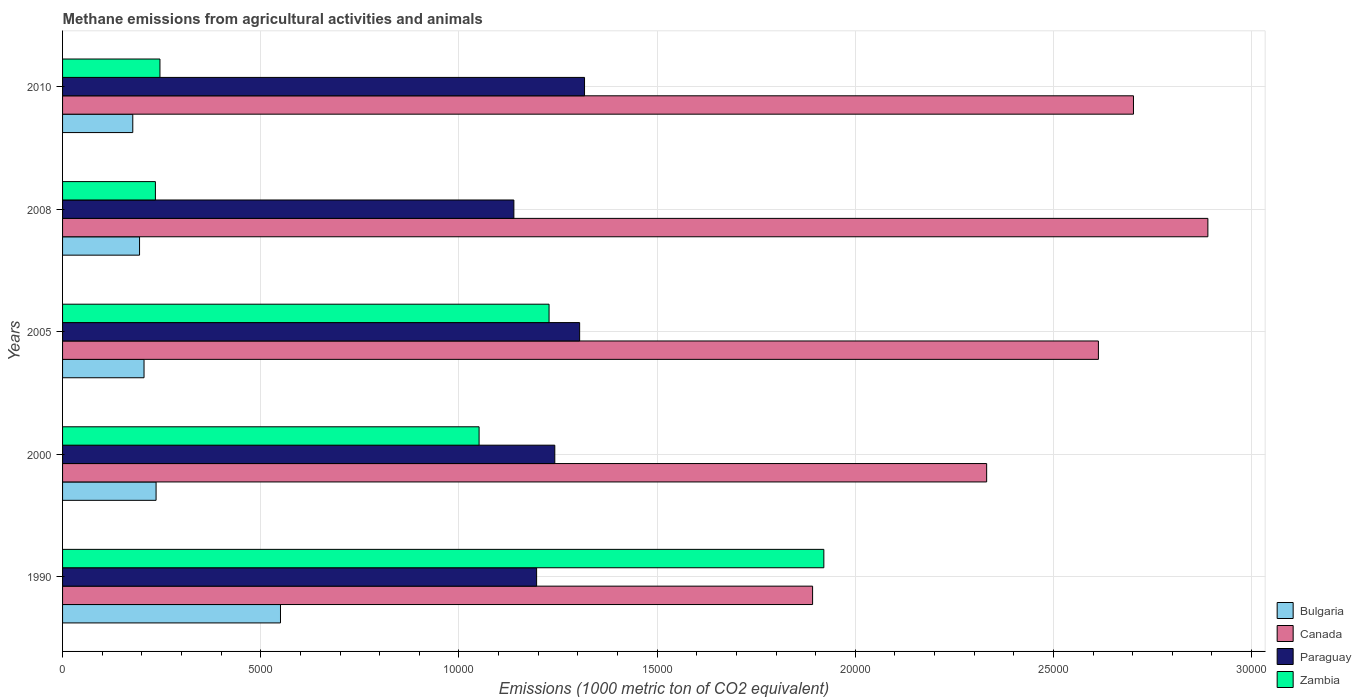How many different coloured bars are there?
Offer a very short reply. 4. Are the number of bars per tick equal to the number of legend labels?
Ensure brevity in your answer.  Yes. Are the number of bars on each tick of the Y-axis equal?
Offer a terse response. Yes. How many bars are there on the 3rd tick from the bottom?
Keep it short and to the point. 4. What is the label of the 5th group of bars from the top?
Offer a terse response. 1990. What is the amount of methane emitted in Zambia in 2010?
Keep it short and to the point. 2457.2. Across all years, what is the maximum amount of methane emitted in Bulgaria?
Your response must be concise. 5498.3. Across all years, what is the minimum amount of methane emitted in Zambia?
Offer a very short reply. 2342.5. What is the total amount of methane emitted in Canada in the graph?
Your answer should be compact. 1.24e+05. What is the difference between the amount of methane emitted in Zambia in 1990 and that in 2008?
Give a very brief answer. 1.69e+04. What is the difference between the amount of methane emitted in Paraguay in 2000 and the amount of methane emitted in Bulgaria in 2008?
Provide a succinct answer. 1.05e+04. What is the average amount of methane emitted in Canada per year?
Provide a short and direct response. 2.49e+04. In the year 1990, what is the difference between the amount of methane emitted in Paraguay and amount of methane emitted in Canada?
Offer a terse response. -6963.1. In how many years, is the amount of methane emitted in Zambia greater than 13000 1000 metric ton?
Offer a very short reply. 1. What is the ratio of the amount of methane emitted in Canada in 2000 to that in 2010?
Your answer should be compact. 0.86. Is the amount of methane emitted in Canada in 2000 less than that in 2005?
Make the answer very short. Yes. Is the difference between the amount of methane emitted in Paraguay in 2008 and 2010 greater than the difference between the amount of methane emitted in Canada in 2008 and 2010?
Make the answer very short. No. What is the difference between the highest and the second highest amount of methane emitted in Paraguay?
Your answer should be very brief. 123.2. What is the difference between the highest and the lowest amount of methane emitted in Canada?
Your answer should be very brief. 9973.1. In how many years, is the amount of methane emitted in Canada greater than the average amount of methane emitted in Canada taken over all years?
Keep it short and to the point. 3. Is the sum of the amount of methane emitted in Bulgaria in 2000 and 2005 greater than the maximum amount of methane emitted in Zambia across all years?
Make the answer very short. No. Is it the case that in every year, the sum of the amount of methane emitted in Paraguay and amount of methane emitted in Zambia is greater than the sum of amount of methane emitted in Canada and amount of methane emitted in Bulgaria?
Offer a terse response. No. What does the 2nd bar from the bottom in 2005 represents?
Make the answer very short. Canada. How many bars are there?
Ensure brevity in your answer.  20. How many years are there in the graph?
Your answer should be very brief. 5. Are the values on the major ticks of X-axis written in scientific E-notation?
Ensure brevity in your answer.  No. Where does the legend appear in the graph?
Provide a succinct answer. Bottom right. How many legend labels are there?
Your response must be concise. 4. How are the legend labels stacked?
Provide a succinct answer. Vertical. What is the title of the graph?
Your response must be concise. Methane emissions from agricultural activities and animals. What is the label or title of the X-axis?
Your response must be concise. Emissions (1000 metric ton of CO2 equivalent). What is the Emissions (1000 metric ton of CO2 equivalent) in Bulgaria in 1990?
Your answer should be compact. 5498.3. What is the Emissions (1000 metric ton of CO2 equivalent) of Canada in 1990?
Provide a short and direct response. 1.89e+04. What is the Emissions (1000 metric ton of CO2 equivalent) in Paraguay in 1990?
Your answer should be very brief. 1.20e+04. What is the Emissions (1000 metric ton of CO2 equivalent) of Zambia in 1990?
Make the answer very short. 1.92e+04. What is the Emissions (1000 metric ton of CO2 equivalent) in Bulgaria in 2000?
Keep it short and to the point. 2359.5. What is the Emissions (1000 metric ton of CO2 equivalent) in Canada in 2000?
Ensure brevity in your answer.  2.33e+04. What is the Emissions (1000 metric ton of CO2 equivalent) in Paraguay in 2000?
Make the answer very short. 1.24e+04. What is the Emissions (1000 metric ton of CO2 equivalent) in Zambia in 2000?
Give a very brief answer. 1.05e+04. What is the Emissions (1000 metric ton of CO2 equivalent) in Bulgaria in 2005?
Offer a very short reply. 2055.2. What is the Emissions (1000 metric ton of CO2 equivalent) of Canada in 2005?
Make the answer very short. 2.61e+04. What is the Emissions (1000 metric ton of CO2 equivalent) in Paraguay in 2005?
Your response must be concise. 1.30e+04. What is the Emissions (1000 metric ton of CO2 equivalent) of Zambia in 2005?
Give a very brief answer. 1.23e+04. What is the Emissions (1000 metric ton of CO2 equivalent) of Bulgaria in 2008?
Make the answer very short. 1942.2. What is the Emissions (1000 metric ton of CO2 equivalent) of Canada in 2008?
Offer a very short reply. 2.89e+04. What is the Emissions (1000 metric ton of CO2 equivalent) of Paraguay in 2008?
Your answer should be very brief. 1.14e+04. What is the Emissions (1000 metric ton of CO2 equivalent) in Zambia in 2008?
Offer a very short reply. 2342.5. What is the Emissions (1000 metric ton of CO2 equivalent) of Bulgaria in 2010?
Provide a short and direct response. 1771.6. What is the Emissions (1000 metric ton of CO2 equivalent) of Canada in 2010?
Make the answer very short. 2.70e+04. What is the Emissions (1000 metric ton of CO2 equivalent) in Paraguay in 2010?
Keep it short and to the point. 1.32e+04. What is the Emissions (1000 metric ton of CO2 equivalent) of Zambia in 2010?
Provide a short and direct response. 2457.2. Across all years, what is the maximum Emissions (1000 metric ton of CO2 equivalent) in Bulgaria?
Provide a short and direct response. 5498.3. Across all years, what is the maximum Emissions (1000 metric ton of CO2 equivalent) of Canada?
Offer a very short reply. 2.89e+04. Across all years, what is the maximum Emissions (1000 metric ton of CO2 equivalent) of Paraguay?
Give a very brief answer. 1.32e+04. Across all years, what is the maximum Emissions (1000 metric ton of CO2 equivalent) of Zambia?
Keep it short and to the point. 1.92e+04. Across all years, what is the minimum Emissions (1000 metric ton of CO2 equivalent) of Bulgaria?
Offer a terse response. 1771.6. Across all years, what is the minimum Emissions (1000 metric ton of CO2 equivalent) of Canada?
Your answer should be very brief. 1.89e+04. Across all years, what is the minimum Emissions (1000 metric ton of CO2 equivalent) in Paraguay?
Your response must be concise. 1.14e+04. Across all years, what is the minimum Emissions (1000 metric ton of CO2 equivalent) in Zambia?
Ensure brevity in your answer.  2342.5. What is the total Emissions (1000 metric ton of CO2 equivalent) of Bulgaria in the graph?
Your response must be concise. 1.36e+04. What is the total Emissions (1000 metric ton of CO2 equivalent) of Canada in the graph?
Provide a short and direct response. 1.24e+05. What is the total Emissions (1000 metric ton of CO2 equivalent) in Paraguay in the graph?
Your response must be concise. 6.20e+04. What is the total Emissions (1000 metric ton of CO2 equivalent) of Zambia in the graph?
Give a very brief answer. 4.68e+04. What is the difference between the Emissions (1000 metric ton of CO2 equivalent) in Bulgaria in 1990 and that in 2000?
Give a very brief answer. 3138.8. What is the difference between the Emissions (1000 metric ton of CO2 equivalent) of Canada in 1990 and that in 2000?
Provide a succinct answer. -4391.7. What is the difference between the Emissions (1000 metric ton of CO2 equivalent) of Paraguay in 1990 and that in 2000?
Give a very brief answer. -458.8. What is the difference between the Emissions (1000 metric ton of CO2 equivalent) of Zambia in 1990 and that in 2000?
Provide a short and direct response. 8698.2. What is the difference between the Emissions (1000 metric ton of CO2 equivalent) of Bulgaria in 1990 and that in 2005?
Offer a very short reply. 3443.1. What is the difference between the Emissions (1000 metric ton of CO2 equivalent) in Canada in 1990 and that in 2005?
Offer a very short reply. -7210.8. What is the difference between the Emissions (1000 metric ton of CO2 equivalent) of Paraguay in 1990 and that in 2005?
Keep it short and to the point. -1085.6. What is the difference between the Emissions (1000 metric ton of CO2 equivalent) of Zambia in 1990 and that in 2005?
Your response must be concise. 6932.6. What is the difference between the Emissions (1000 metric ton of CO2 equivalent) of Bulgaria in 1990 and that in 2008?
Give a very brief answer. 3556.1. What is the difference between the Emissions (1000 metric ton of CO2 equivalent) of Canada in 1990 and that in 2008?
Your answer should be compact. -9973.1. What is the difference between the Emissions (1000 metric ton of CO2 equivalent) in Paraguay in 1990 and that in 2008?
Offer a terse response. 573.8. What is the difference between the Emissions (1000 metric ton of CO2 equivalent) in Zambia in 1990 and that in 2008?
Give a very brief answer. 1.69e+04. What is the difference between the Emissions (1000 metric ton of CO2 equivalent) in Bulgaria in 1990 and that in 2010?
Keep it short and to the point. 3726.7. What is the difference between the Emissions (1000 metric ton of CO2 equivalent) of Canada in 1990 and that in 2010?
Your response must be concise. -8095.8. What is the difference between the Emissions (1000 metric ton of CO2 equivalent) in Paraguay in 1990 and that in 2010?
Your answer should be very brief. -1208.8. What is the difference between the Emissions (1000 metric ton of CO2 equivalent) of Zambia in 1990 and that in 2010?
Provide a short and direct response. 1.67e+04. What is the difference between the Emissions (1000 metric ton of CO2 equivalent) in Bulgaria in 2000 and that in 2005?
Offer a terse response. 304.3. What is the difference between the Emissions (1000 metric ton of CO2 equivalent) in Canada in 2000 and that in 2005?
Your answer should be very brief. -2819.1. What is the difference between the Emissions (1000 metric ton of CO2 equivalent) in Paraguay in 2000 and that in 2005?
Give a very brief answer. -626.8. What is the difference between the Emissions (1000 metric ton of CO2 equivalent) of Zambia in 2000 and that in 2005?
Provide a short and direct response. -1765.6. What is the difference between the Emissions (1000 metric ton of CO2 equivalent) of Bulgaria in 2000 and that in 2008?
Your answer should be very brief. 417.3. What is the difference between the Emissions (1000 metric ton of CO2 equivalent) of Canada in 2000 and that in 2008?
Make the answer very short. -5581.4. What is the difference between the Emissions (1000 metric ton of CO2 equivalent) of Paraguay in 2000 and that in 2008?
Provide a succinct answer. 1032.6. What is the difference between the Emissions (1000 metric ton of CO2 equivalent) in Zambia in 2000 and that in 2008?
Offer a very short reply. 8166.4. What is the difference between the Emissions (1000 metric ton of CO2 equivalent) of Bulgaria in 2000 and that in 2010?
Give a very brief answer. 587.9. What is the difference between the Emissions (1000 metric ton of CO2 equivalent) of Canada in 2000 and that in 2010?
Your answer should be very brief. -3704.1. What is the difference between the Emissions (1000 metric ton of CO2 equivalent) of Paraguay in 2000 and that in 2010?
Give a very brief answer. -750. What is the difference between the Emissions (1000 metric ton of CO2 equivalent) in Zambia in 2000 and that in 2010?
Your response must be concise. 8051.7. What is the difference between the Emissions (1000 metric ton of CO2 equivalent) in Bulgaria in 2005 and that in 2008?
Keep it short and to the point. 113. What is the difference between the Emissions (1000 metric ton of CO2 equivalent) in Canada in 2005 and that in 2008?
Offer a terse response. -2762.3. What is the difference between the Emissions (1000 metric ton of CO2 equivalent) in Paraguay in 2005 and that in 2008?
Ensure brevity in your answer.  1659.4. What is the difference between the Emissions (1000 metric ton of CO2 equivalent) in Zambia in 2005 and that in 2008?
Offer a terse response. 9932. What is the difference between the Emissions (1000 metric ton of CO2 equivalent) of Bulgaria in 2005 and that in 2010?
Your answer should be very brief. 283.6. What is the difference between the Emissions (1000 metric ton of CO2 equivalent) of Canada in 2005 and that in 2010?
Your answer should be compact. -885. What is the difference between the Emissions (1000 metric ton of CO2 equivalent) in Paraguay in 2005 and that in 2010?
Your answer should be compact. -123.2. What is the difference between the Emissions (1000 metric ton of CO2 equivalent) of Zambia in 2005 and that in 2010?
Your answer should be compact. 9817.3. What is the difference between the Emissions (1000 metric ton of CO2 equivalent) in Bulgaria in 2008 and that in 2010?
Make the answer very short. 170.6. What is the difference between the Emissions (1000 metric ton of CO2 equivalent) in Canada in 2008 and that in 2010?
Offer a terse response. 1877.3. What is the difference between the Emissions (1000 metric ton of CO2 equivalent) of Paraguay in 2008 and that in 2010?
Your answer should be very brief. -1782.6. What is the difference between the Emissions (1000 metric ton of CO2 equivalent) of Zambia in 2008 and that in 2010?
Provide a short and direct response. -114.7. What is the difference between the Emissions (1000 metric ton of CO2 equivalent) of Bulgaria in 1990 and the Emissions (1000 metric ton of CO2 equivalent) of Canada in 2000?
Your answer should be very brief. -1.78e+04. What is the difference between the Emissions (1000 metric ton of CO2 equivalent) in Bulgaria in 1990 and the Emissions (1000 metric ton of CO2 equivalent) in Paraguay in 2000?
Your response must be concise. -6920.9. What is the difference between the Emissions (1000 metric ton of CO2 equivalent) in Bulgaria in 1990 and the Emissions (1000 metric ton of CO2 equivalent) in Zambia in 2000?
Offer a very short reply. -5010.6. What is the difference between the Emissions (1000 metric ton of CO2 equivalent) of Canada in 1990 and the Emissions (1000 metric ton of CO2 equivalent) of Paraguay in 2000?
Give a very brief answer. 6504.3. What is the difference between the Emissions (1000 metric ton of CO2 equivalent) of Canada in 1990 and the Emissions (1000 metric ton of CO2 equivalent) of Zambia in 2000?
Provide a succinct answer. 8414.6. What is the difference between the Emissions (1000 metric ton of CO2 equivalent) in Paraguay in 1990 and the Emissions (1000 metric ton of CO2 equivalent) in Zambia in 2000?
Your response must be concise. 1451.5. What is the difference between the Emissions (1000 metric ton of CO2 equivalent) of Bulgaria in 1990 and the Emissions (1000 metric ton of CO2 equivalent) of Canada in 2005?
Your answer should be very brief. -2.06e+04. What is the difference between the Emissions (1000 metric ton of CO2 equivalent) of Bulgaria in 1990 and the Emissions (1000 metric ton of CO2 equivalent) of Paraguay in 2005?
Offer a terse response. -7547.7. What is the difference between the Emissions (1000 metric ton of CO2 equivalent) in Bulgaria in 1990 and the Emissions (1000 metric ton of CO2 equivalent) in Zambia in 2005?
Your answer should be very brief. -6776.2. What is the difference between the Emissions (1000 metric ton of CO2 equivalent) in Canada in 1990 and the Emissions (1000 metric ton of CO2 equivalent) in Paraguay in 2005?
Provide a short and direct response. 5877.5. What is the difference between the Emissions (1000 metric ton of CO2 equivalent) in Canada in 1990 and the Emissions (1000 metric ton of CO2 equivalent) in Zambia in 2005?
Ensure brevity in your answer.  6649. What is the difference between the Emissions (1000 metric ton of CO2 equivalent) in Paraguay in 1990 and the Emissions (1000 metric ton of CO2 equivalent) in Zambia in 2005?
Keep it short and to the point. -314.1. What is the difference between the Emissions (1000 metric ton of CO2 equivalent) in Bulgaria in 1990 and the Emissions (1000 metric ton of CO2 equivalent) in Canada in 2008?
Provide a short and direct response. -2.34e+04. What is the difference between the Emissions (1000 metric ton of CO2 equivalent) in Bulgaria in 1990 and the Emissions (1000 metric ton of CO2 equivalent) in Paraguay in 2008?
Provide a short and direct response. -5888.3. What is the difference between the Emissions (1000 metric ton of CO2 equivalent) of Bulgaria in 1990 and the Emissions (1000 metric ton of CO2 equivalent) of Zambia in 2008?
Your answer should be compact. 3155.8. What is the difference between the Emissions (1000 metric ton of CO2 equivalent) of Canada in 1990 and the Emissions (1000 metric ton of CO2 equivalent) of Paraguay in 2008?
Ensure brevity in your answer.  7536.9. What is the difference between the Emissions (1000 metric ton of CO2 equivalent) of Canada in 1990 and the Emissions (1000 metric ton of CO2 equivalent) of Zambia in 2008?
Offer a terse response. 1.66e+04. What is the difference between the Emissions (1000 metric ton of CO2 equivalent) of Paraguay in 1990 and the Emissions (1000 metric ton of CO2 equivalent) of Zambia in 2008?
Your answer should be very brief. 9617.9. What is the difference between the Emissions (1000 metric ton of CO2 equivalent) in Bulgaria in 1990 and the Emissions (1000 metric ton of CO2 equivalent) in Canada in 2010?
Offer a very short reply. -2.15e+04. What is the difference between the Emissions (1000 metric ton of CO2 equivalent) of Bulgaria in 1990 and the Emissions (1000 metric ton of CO2 equivalent) of Paraguay in 2010?
Your answer should be very brief. -7670.9. What is the difference between the Emissions (1000 metric ton of CO2 equivalent) of Bulgaria in 1990 and the Emissions (1000 metric ton of CO2 equivalent) of Zambia in 2010?
Offer a very short reply. 3041.1. What is the difference between the Emissions (1000 metric ton of CO2 equivalent) of Canada in 1990 and the Emissions (1000 metric ton of CO2 equivalent) of Paraguay in 2010?
Keep it short and to the point. 5754.3. What is the difference between the Emissions (1000 metric ton of CO2 equivalent) of Canada in 1990 and the Emissions (1000 metric ton of CO2 equivalent) of Zambia in 2010?
Make the answer very short. 1.65e+04. What is the difference between the Emissions (1000 metric ton of CO2 equivalent) in Paraguay in 1990 and the Emissions (1000 metric ton of CO2 equivalent) in Zambia in 2010?
Keep it short and to the point. 9503.2. What is the difference between the Emissions (1000 metric ton of CO2 equivalent) of Bulgaria in 2000 and the Emissions (1000 metric ton of CO2 equivalent) of Canada in 2005?
Offer a very short reply. -2.38e+04. What is the difference between the Emissions (1000 metric ton of CO2 equivalent) in Bulgaria in 2000 and the Emissions (1000 metric ton of CO2 equivalent) in Paraguay in 2005?
Provide a short and direct response. -1.07e+04. What is the difference between the Emissions (1000 metric ton of CO2 equivalent) of Bulgaria in 2000 and the Emissions (1000 metric ton of CO2 equivalent) of Zambia in 2005?
Offer a very short reply. -9915. What is the difference between the Emissions (1000 metric ton of CO2 equivalent) in Canada in 2000 and the Emissions (1000 metric ton of CO2 equivalent) in Paraguay in 2005?
Make the answer very short. 1.03e+04. What is the difference between the Emissions (1000 metric ton of CO2 equivalent) of Canada in 2000 and the Emissions (1000 metric ton of CO2 equivalent) of Zambia in 2005?
Offer a very short reply. 1.10e+04. What is the difference between the Emissions (1000 metric ton of CO2 equivalent) of Paraguay in 2000 and the Emissions (1000 metric ton of CO2 equivalent) of Zambia in 2005?
Offer a very short reply. 144.7. What is the difference between the Emissions (1000 metric ton of CO2 equivalent) of Bulgaria in 2000 and the Emissions (1000 metric ton of CO2 equivalent) of Canada in 2008?
Keep it short and to the point. -2.65e+04. What is the difference between the Emissions (1000 metric ton of CO2 equivalent) of Bulgaria in 2000 and the Emissions (1000 metric ton of CO2 equivalent) of Paraguay in 2008?
Provide a succinct answer. -9027.1. What is the difference between the Emissions (1000 metric ton of CO2 equivalent) in Bulgaria in 2000 and the Emissions (1000 metric ton of CO2 equivalent) in Zambia in 2008?
Keep it short and to the point. 17. What is the difference between the Emissions (1000 metric ton of CO2 equivalent) in Canada in 2000 and the Emissions (1000 metric ton of CO2 equivalent) in Paraguay in 2008?
Keep it short and to the point. 1.19e+04. What is the difference between the Emissions (1000 metric ton of CO2 equivalent) of Canada in 2000 and the Emissions (1000 metric ton of CO2 equivalent) of Zambia in 2008?
Give a very brief answer. 2.10e+04. What is the difference between the Emissions (1000 metric ton of CO2 equivalent) of Paraguay in 2000 and the Emissions (1000 metric ton of CO2 equivalent) of Zambia in 2008?
Give a very brief answer. 1.01e+04. What is the difference between the Emissions (1000 metric ton of CO2 equivalent) in Bulgaria in 2000 and the Emissions (1000 metric ton of CO2 equivalent) in Canada in 2010?
Offer a terse response. -2.47e+04. What is the difference between the Emissions (1000 metric ton of CO2 equivalent) in Bulgaria in 2000 and the Emissions (1000 metric ton of CO2 equivalent) in Paraguay in 2010?
Provide a succinct answer. -1.08e+04. What is the difference between the Emissions (1000 metric ton of CO2 equivalent) in Bulgaria in 2000 and the Emissions (1000 metric ton of CO2 equivalent) in Zambia in 2010?
Ensure brevity in your answer.  -97.7. What is the difference between the Emissions (1000 metric ton of CO2 equivalent) in Canada in 2000 and the Emissions (1000 metric ton of CO2 equivalent) in Paraguay in 2010?
Your answer should be very brief. 1.01e+04. What is the difference between the Emissions (1000 metric ton of CO2 equivalent) in Canada in 2000 and the Emissions (1000 metric ton of CO2 equivalent) in Zambia in 2010?
Your answer should be very brief. 2.09e+04. What is the difference between the Emissions (1000 metric ton of CO2 equivalent) of Paraguay in 2000 and the Emissions (1000 metric ton of CO2 equivalent) of Zambia in 2010?
Provide a succinct answer. 9962. What is the difference between the Emissions (1000 metric ton of CO2 equivalent) in Bulgaria in 2005 and the Emissions (1000 metric ton of CO2 equivalent) in Canada in 2008?
Ensure brevity in your answer.  -2.68e+04. What is the difference between the Emissions (1000 metric ton of CO2 equivalent) of Bulgaria in 2005 and the Emissions (1000 metric ton of CO2 equivalent) of Paraguay in 2008?
Provide a succinct answer. -9331.4. What is the difference between the Emissions (1000 metric ton of CO2 equivalent) of Bulgaria in 2005 and the Emissions (1000 metric ton of CO2 equivalent) of Zambia in 2008?
Your response must be concise. -287.3. What is the difference between the Emissions (1000 metric ton of CO2 equivalent) of Canada in 2005 and the Emissions (1000 metric ton of CO2 equivalent) of Paraguay in 2008?
Your answer should be very brief. 1.47e+04. What is the difference between the Emissions (1000 metric ton of CO2 equivalent) of Canada in 2005 and the Emissions (1000 metric ton of CO2 equivalent) of Zambia in 2008?
Provide a short and direct response. 2.38e+04. What is the difference between the Emissions (1000 metric ton of CO2 equivalent) in Paraguay in 2005 and the Emissions (1000 metric ton of CO2 equivalent) in Zambia in 2008?
Provide a succinct answer. 1.07e+04. What is the difference between the Emissions (1000 metric ton of CO2 equivalent) of Bulgaria in 2005 and the Emissions (1000 metric ton of CO2 equivalent) of Canada in 2010?
Give a very brief answer. -2.50e+04. What is the difference between the Emissions (1000 metric ton of CO2 equivalent) of Bulgaria in 2005 and the Emissions (1000 metric ton of CO2 equivalent) of Paraguay in 2010?
Keep it short and to the point. -1.11e+04. What is the difference between the Emissions (1000 metric ton of CO2 equivalent) of Bulgaria in 2005 and the Emissions (1000 metric ton of CO2 equivalent) of Zambia in 2010?
Make the answer very short. -402. What is the difference between the Emissions (1000 metric ton of CO2 equivalent) in Canada in 2005 and the Emissions (1000 metric ton of CO2 equivalent) in Paraguay in 2010?
Make the answer very short. 1.30e+04. What is the difference between the Emissions (1000 metric ton of CO2 equivalent) of Canada in 2005 and the Emissions (1000 metric ton of CO2 equivalent) of Zambia in 2010?
Provide a succinct answer. 2.37e+04. What is the difference between the Emissions (1000 metric ton of CO2 equivalent) of Paraguay in 2005 and the Emissions (1000 metric ton of CO2 equivalent) of Zambia in 2010?
Ensure brevity in your answer.  1.06e+04. What is the difference between the Emissions (1000 metric ton of CO2 equivalent) of Bulgaria in 2008 and the Emissions (1000 metric ton of CO2 equivalent) of Canada in 2010?
Your response must be concise. -2.51e+04. What is the difference between the Emissions (1000 metric ton of CO2 equivalent) in Bulgaria in 2008 and the Emissions (1000 metric ton of CO2 equivalent) in Paraguay in 2010?
Your response must be concise. -1.12e+04. What is the difference between the Emissions (1000 metric ton of CO2 equivalent) in Bulgaria in 2008 and the Emissions (1000 metric ton of CO2 equivalent) in Zambia in 2010?
Give a very brief answer. -515. What is the difference between the Emissions (1000 metric ton of CO2 equivalent) in Canada in 2008 and the Emissions (1000 metric ton of CO2 equivalent) in Paraguay in 2010?
Your response must be concise. 1.57e+04. What is the difference between the Emissions (1000 metric ton of CO2 equivalent) of Canada in 2008 and the Emissions (1000 metric ton of CO2 equivalent) of Zambia in 2010?
Offer a very short reply. 2.64e+04. What is the difference between the Emissions (1000 metric ton of CO2 equivalent) of Paraguay in 2008 and the Emissions (1000 metric ton of CO2 equivalent) of Zambia in 2010?
Make the answer very short. 8929.4. What is the average Emissions (1000 metric ton of CO2 equivalent) in Bulgaria per year?
Provide a short and direct response. 2725.36. What is the average Emissions (1000 metric ton of CO2 equivalent) of Canada per year?
Provide a succinct answer. 2.49e+04. What is the average Emissions (1000 metric ton of CO2 equivalent) of Paraguay per year?
Your response must be concise. 1.24e+04. What is the average Emissions (1000 metric ton of CO2 equivalent) in Zambia per year?
Give a very brief answer. 9358.04. In the year 1990, what is the difference between the Emissions (1000 metric ton of CO2 equivalent) in Bulgaria and Emissions (1000 metric ton of CO2 equivalent) in Canada?
Give a very brief answer. -1.34e+04. In the year 1990, what is the difference between the Emissions (1000 metric ton of CO2 equivalent) in Bulgaria and Emissions (1000 metric ton of CO2 equivalent) in Paraguay?
Provide a short and direct response. -6462.1. In the year 1990, what is the difference between the Emissions (1000 metric ton of CO2 equivalent) in Bulgaria and Emissions (1000 metric ton of CO2 equivalent) in Zambia?
Your answer should be compact. -1.37e+04. In the year 1990, what is the difference between the Emissions (1000 metric ton of CO2 equivalent) in Canada and Emissions (1000 metric ton of CO2 equivalent) in Paraguay?
Ensure brevity in your answer.  6963.1. In the year 1990, what is the difference between the Emissions (1000 metric ton of CO2 equivalent) in Canada and Emissions (1000 metric ton of CO2 equivalent) in Zambia?
Give a very brief answer. -283.6. In the year 1990, what is the difference between the Emissions (1000 metric ton of CO2 equivalent) in Paraguay and Emissions (1000 metric ton of CO2 equivalent) in Zambia?
Give a very brief answer. -7246.7. In the year 2000, what is the difference between the Emissions (1000 metric ton of CO2 equivalent) in Bulgaria and Emissions (1000 metric ton of CO2 equivalent) in Canada?
Your answer should be very brief. -2.10e+04. In the year 2000, what is the difference between the Emissions (1000 metric ton of CO2 equivalent) in Bulgaria and Emissions (1000 metric ton of CO2 equivalent) in Paraguay?
Offer a very short reply. -1.01e+04. In the year 2000, what is the difference between the Emissions (1000 metric ton of CO2 equivalent) in Bulgaria and Emissions (1000 metric ton of CO2 equivalent) in Zambia?
Ensure brevity in your answer.  -8149.4. In the year 2000, what is the difference between the Emissions (1000 metric ton of CO2 equivalent) in Canada and Emissions (1000 metric ton of CO2 equivalent) in Paraguay?
Ensure brevity in your answer.  1.09e+04. In the year 2000, what is the difference between the Emissions (1000 metric ton of CO2 equivalent) of Canada and Emissions (1000 metric ton of CO2 equivalent) of Zambia?
Provide a short and direct response. 1.28e+04. In the year 2000, what is the difference between the Emissions (1000 metric ton of CO2 equivalent) in Paraguay and Emissions (1000 metric ton of CO2 equivalent) in Zambia?
Your answer should be very brief. 1910.3. In the year 2005, what is the difference between the Emissions (1000 metric ton of CO2 equivalent) in Bulgaria and Emissions (1000 metric ton of CO2 equivalent) in Canada?
Provide a succinct answer. -2.41e+04. In the year 2005, what is the difference between the Emissions (1000 metric ton of CO2 equivalent) in Bulgaria and Emissions (1000 metric ton of CO2 equivalent) in Paraguay?
Provide a short and direct response. -1.10e+04. In the year 2005, what is the difference between the Emissions (1000 metric ton of CO2 equivalent) in Bulgaria and Emissions (1000 metric ton of CO2 equivalent) in Zambia?
Offer a very short reply. -1.02e+04. In the year 2005, what is the difference between the Emissions (1000 metric ton of CO2 equivalent) of Canada and Emissions (1000 metric ton of CO2 equivalent) of Paraguay?
Offer a terse response. 1.31e+04. In the year 2005, what is the difference between the Emissions (1000 metric ton of CO2 equivalent) in Canada and Emissions (1000 metric ton of CO2 equivalent) in Zambia?
Your answer should be compact. 1.39e+04. In the year 2005, what is the difference between the Emissions (1000 metric ton of CO2 equivalent) in Paraguay and Emissions (1000 metric ton of CO2 equivalent) in Zambia?
Keep it short and to the point. 771.5. In the year 2008, what is the difference between the Emissions (1000 metric ton of CO2 equivalent) of Bulgaria and Emissions (1000 metric ton of CO2 equivalent) of Canada?
Your answer should be very brief. -2.70e+04. In the year 2008, what is the difference between the Emissions (1000 metric ton of CO2 equivalent) of Bulgaria and Emissions (1000 metric ton of CO2 equivalent) of Paraguay?
Provide a short and direct response. -9444.4. In the year 2008, what is the difference between the Emissions (1000 metric ton of CO2 equivalent) of Bulgaria and Emissions (1000 metric ton of CO2 equivalent) of Zambia?
Keep it short and to the point. -400.3. In the year 2008, what is the difference between the Emissions (1000 metric ton of CO2 equivalent) in Canada and Emissions (1000 metric ton of CO2 equivalent) in Paraguay?
Make the answer very short. 1.75e+04. In the year 2008, what is the difference between the Emissions (1000 metric ton of CO2 equivalent) in Canada and Emissions (1000 metric ton of CO2 equivalent) in Zambia?
Provide a short and direct response. 2.66e+04. In the year 2008, what is the difference between the Emissions (1000 metric ton of CO2 equivalent) in Paraguay and Emissions (1000 metric ton of CO2 equivalent) in Zambia?
Provide a succinct answer. 9044.1. In the year 2010, what is the difference between the Emissions (1000 metric ton of CO2 equivalent) in Bulgaria and Emissions (1000 metric ton of CO2 equivalent) in Canada?
Your answer should be very brief. -2.52e+04. In the year 2010, what is the difference between the Emissions (1000 metric ton of CO2 equivalent) of Bulgaria and Emissions (1000 metric ton of CO2 equivalent) of Paraguay?
Your answer should be compact. -1.14e+04. In the year 2010, what is the difference between the Emissions (1000 metric ton of CO2 equivalent) in Bulgaria and Emissions (1000 metric ton of CO2 equivalent) in Zambia?
Give a very brief answer. -685.6. In the year 2010, what is the difference between the Emissions (1000 metric ton of CO2 equivalent) in Canada and Emissions (1000 metric ton of CO2 equivalent) in Paraguay?
Offer a very short reply. 1.39e+04. In the year 2010, what is the difference between the Emissions (1000 metric ton of CO2 equivalent) in Canada and Emissions (1000 metric ton of CO2 equivalent) in Zambia?
Give a very brief answer. 2.46e+04. In the year 2010, what is the difference between the Emissions (1000 metric ton of CO2 equivalent) in Paraguay and Emissions (1000 metric ton of CO2 equivalent) in Zambia?
Provide a succinct answer. 1.07e+04. What is the ratio of the Emissions (1000 metric ton of CO2 equivalent) in Bulgaria in 1990 to that in 2000?
Offer a very short reply. 2.33. What is the ratio of the Emissions (1000 metric ton of CO2 equivalent) of Canada in 1990 to that in 2000?
Provide a short and direct response. 0.81. What is the ratio of the Emissions (1000 metric ton of CO2 equivalent) of Paraguay in 1990 to that in 2000?
Your response must be concise. 0.96. What is the ratio of the Emissions (1000 metric ton of CO2 equivalent) of Zambia in 1990 to that in 2000?
Your answer should be very brief. 1.83. What is the ratio of the Emissions (1000 metric ton of CO2 equivalent) in Bulgaria in 1990 to that in 2005?
Your answer should be compact. 2.68. What is the ratio of the Emissions (1000 metric ton of CO2 equivalent) in Canada in 1990 to that in 2005?
Offer a very short reply. 0.72. What is the ratio of the Emissions (1000 metric ton of CO2 equivalent) in Paraguay in 1990 to that in 2005?
Provide a short and direct response. 0.92. What is the ratio of the Emissions (1000 metric ton of CO2 equivalent) of Zambia in 1990 to that in 2005?
Make the answer very short. 1.56. What is the ratio of the Emissions (1000 metric ton of CO2 equivalent) in Bulgaria in 1990 to that in 2008?
Keep it short and to the point. 2.83. What is the ratio of the Emissions (1000 metric ton of CO2 equivalent) of Canada in 1990 to that in 2008?
Ensure brevity in your answer.  0.65. What is the ratio of the Emissions (1000 metric ton of CO2 equivalent) in Paraguay in 1990 to that in 2008?
Your answer should be very brief. 1.05. What is the ratio of the Emissions (1000 metric ton of CO2 equivalent) of Zambia in 1990 to that in 2008?
Your answer should be very brief. 8.2. What is the ratio of the Emissions (1000 metric ton of CO2 equivalent) of Bulgaria in 1990 to that in 2010?
Offer a very short reply. 3.1. What is the ratio of the Emissions (1000 metric ton of CO2 equivalent) of Canada in 1990 to that in 2010?
Offer a terse response. 0.7. What is the ratio of the Emissions (1000 metric ton of CO2 equivalent) of Paraguay in 1990 to that in 2010?
Your response must be concise. 0.91. What is the ratio of the Emissions (1000 metric ton of CO2 equivalent) in Zambia in 1990 to that in 2010?
Offer a very short reply. 7.82. What is the ratio of the Emissions (1000 metric ton of CO2 equivalent) in Bulgaria in 2000 to that in 2005?
Provide a succinct answer. 1.15. What is the ratio of the Emissions (1000 metric ton of CO2 equivalent) in Canada in 2000 to that in 2005?
Offer a very short reply. 0.89. What is the ratio of the Emissions (1000 metric ton of CO2 equivalent) in Zambia in 2000 to that in 2005?
Your response must be concise. 0.86. What is the ratio of the Emissions (1000 metric ton of CO2 equivalent) in Bulgaria in 2000 to that in 2008?
Your response must be concise. 1.21. What is the ratio of the Emissions (1000 metric ton of CO2 equivalent) in Canada in 2000 to that in 2008?
Keep it short and to the point. 0.81. What is the ratio of the Emissions (1000 metric ton of CO2 equivalent) of Paraguay in 2000 to that in 2008?
Ensure brevity in your answer.  1.09. What is the ratio of the Emissions (1000 metric ton of CO2 equivalent) of Zambia in 2000 to that in 2008?
Offer a very short reply. 4.49. What is the ratio of the Emissions (1000 metric ton of CO2 equivalent) in Bulgaria in 2000 to that in 2010?
Offer a very short reply. 1.33. What is the ratio of the Emissions (1000 metric ton of CO2 equivalent) of Canada in 2000 to that in 2010?
Provide a succinct answer. 0.86. What is the ratio of the Emissions (1000 metric ton of CO2 equivalent) of Paraguay in 2000 to that in 2010?
Ensure brevity in your answer.  0.94. What is the ratio of the Emissions (1000 metric ton of CO2 equivalent) in Zambia in 2000 to that in 2010?
Offer a very short reply. 4.28. What is the ratio of the Emissions (1000 metric ton of CO2 equivalent) in Bulgaria in 2005 to that in 2008?
Offer a very short reply. 1.06. What is the ratio of the Emissions (1000 metric ton of CO2 equivalent) of Canada in 2005 to that in 2008?
Your answer should be compact. 0.9. What is the ratio of the Emissions (1000 metric ton of CO2 equivalent) of Paraguay in 2005 to that in 2008?
Keep it short and to the point. 1.15. What is the ratio of the Emissions (1000 metric ton of CO2 equivalent) of Zambia in 2005 to that in 2008?
Offer a very short reply. 5.24. What is the ratio of the Emissions (1000 metric ton of CO2 equivalent) in Bulgaria in 2005 to that in 2010?
Provide a succinct answer. 1.16. What is the ratio of the Emissions (1000 metric ton of CO2 equivalent) of Canada in 2005 to that in 2010?
Your answer should be compact. 0.97. What is the ratio of the Emissions (1000 metric ton of CO2 equivalent) in Paraguay in 2005 to that in 2010?
Ensure brevity in your answer.  0.99. What is the ratio of the Emissions (1000 metric ton of CO2 equivalent) in Zambia in 2005 to that in 2010?
Give a very brief answer. 5. What is the ratio of the Emissions (1000 metric ton of CO2 equivalent) in Bulgaria in 2008 to that in 2010?
Your answer should be compact. 1.1. What is the ratio of the Emissions (1000 metric ton of CO2 equivalent) in Canada in 2008 to that in 2010?
Provide a short and direct response. 1.07. What is the ratio of the Emissions (1000 metric ton of CO2 equivalent) in Paraguay in 2008 to that in 2010?
Offer a terse response. 0.86. What is the ratio of the Emissions (1000 metric ton of CO2 equivalent) in Zambia in 2008 to that in 2010?
Your response must be concise. 0.95. What is the difference between the highest and the second highest Emissions (1000 metric ton of CO2 equivalent) in Bulgaria?
Provide a succinct answer. 3138.8. What is the difference between the highest and the second highest Emissions (1000 metric ton of CO2 equivalent) of Canada?
Give a very brief answer. 1877.3. What is the difference between the highest and the second highest Emissions (1000 metric ton of CO2 equivalent) in Paraguay?
Offer a very short reply. 123.2. What is the difference between the highest and the second highest Emissions (1000 metric ton of CO2 equivalent) in Zambia?
Your answer should be compact. 6932.6. What is the difference between the highest and the lowest Emissions (1000 metric ton of CO2 equivalent) in Bulgaria?
Your response must be concise. 3726.7. What is the difference between the highest and the lowest Emissions (1000 metric ton of CO2 equivalent) in Canada?
Make the answer very short. 9973.1. What is the difference between the highest and the lowest Emissions (1000 metric ton of CO2 equivalent) of Paraguay?
Offer a very short reply. 1782.6. What is the difference between the highest and the lowest Emissions (1000 metric ton of CO2 equivalent) of Zambia?
Your answer should be very brief. 1.69e+04. 